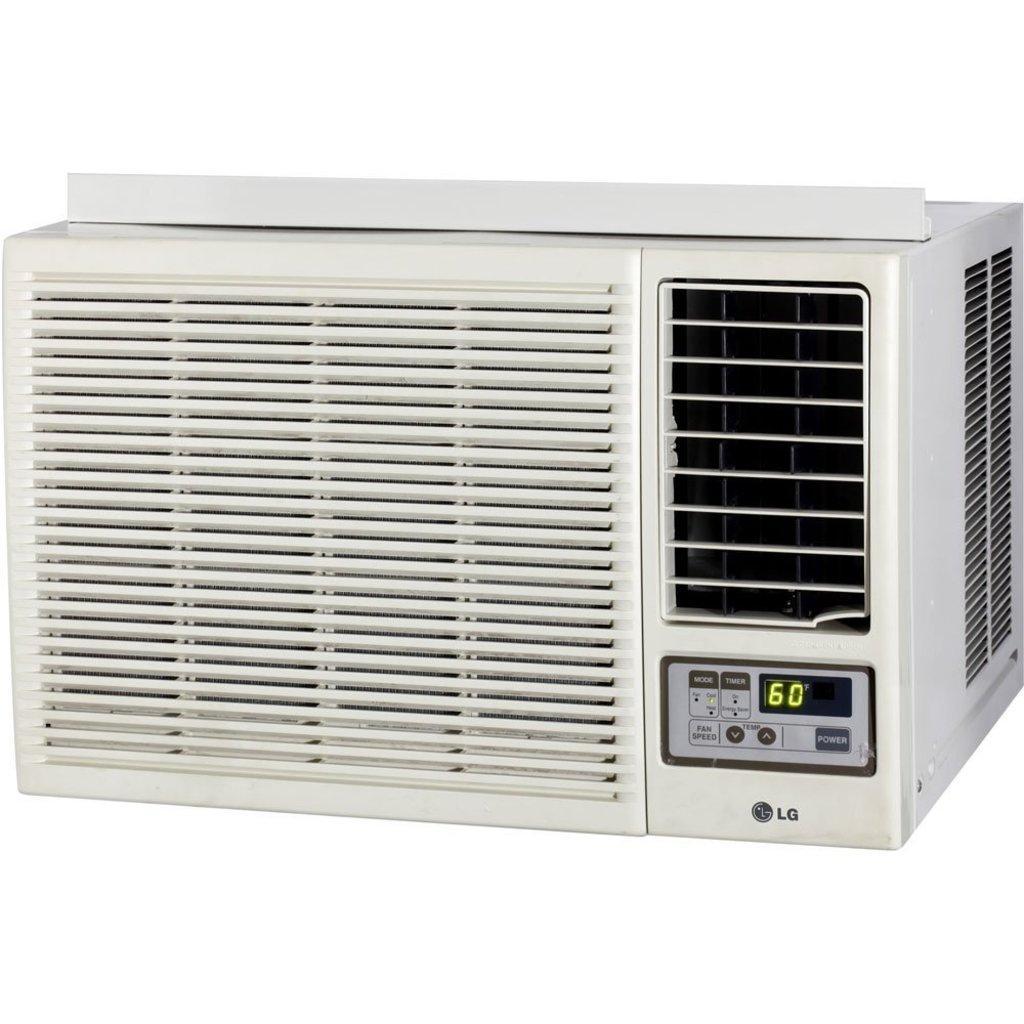Can you describe this image briefly? In the picture I can see white color machine. The background of the image is white. 